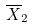Convert formula to latex. <formula><loc_0><loc_0><loc_500><loc_500>\overline { X } _ { 2 }</formula> 